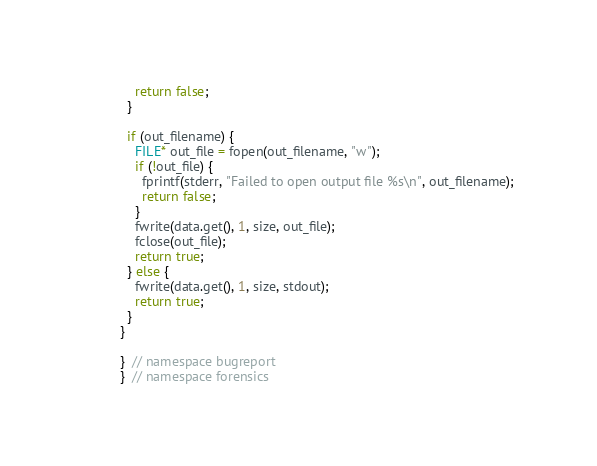<code> <loc_0><loc_0><loc_500><loc_500><_C++_>    return false;
  }

  if (out_filename) {
    FILE* out_file = fopen(out_filename, "w");
    if (!out_file) {
      fprintf(stderr, "Failed to open output file %s\n", out_filename);
      return false;
    }
    fwrite(data.get(), 1, size, out_file);
    fclose(out_file);
    return true;
  } else {
    fwrite(data.get(), 1, size, stdout);
    return true;
  }
}

}  // namespace bugreport
}  // namespace forensics
</code> 